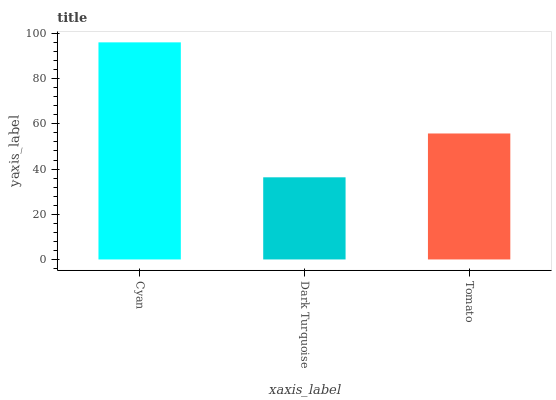Is Dark Turquoise the minimum?
Answer yes or no. Yes. Is Cyan the maximum?
Answer yes or no. Yes. Is Tomato the minimum?
Answer yes or no. No. Is Tomato the maximum?
Answer yes or no. No. Is Tomato greater than Dark Turquoise?
Answer yes or no. Yes. Is Dark Turquoise less than Tomato?
Answer yes or no. Yes. Is Dark Turquoise greater than Tomato?
Answer yes or no. No. Is Tomato less than Dark Turquoise?
Answer yes or no. No. Is Tomato the high median?
Answer yes or no. Yes. Is Tomato the low median?
Answer yes or no. Yes. Is Cyan the high median?
Answer yes or no. No. Is Cyan the low median?
Answer yes or no. No. 